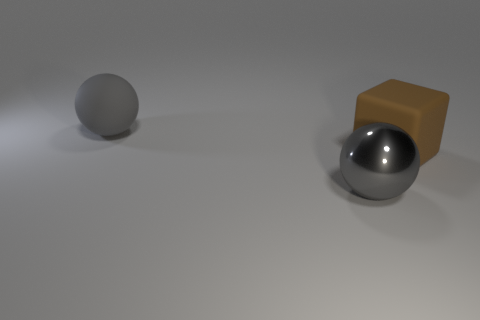Add 1 tiny purple matte balls. How many objects exist? 4 Subtract all cubes. How many objects are left? 2 Subtract 1 blocks. How many blocks are left? 0 Add 2 big matte cubes. How many big matte cubes are left? 3 Add 2 large brown things. How many large brown things exist? 3 Subtract 1 brown blocks. How many objects are left? 2 Subtract all purple blocks. Subtract all green cylinders. How many blocks are left? 1 Subtract all big rubber cubes. Subtract all matte spheres. How many objects are left? 1 